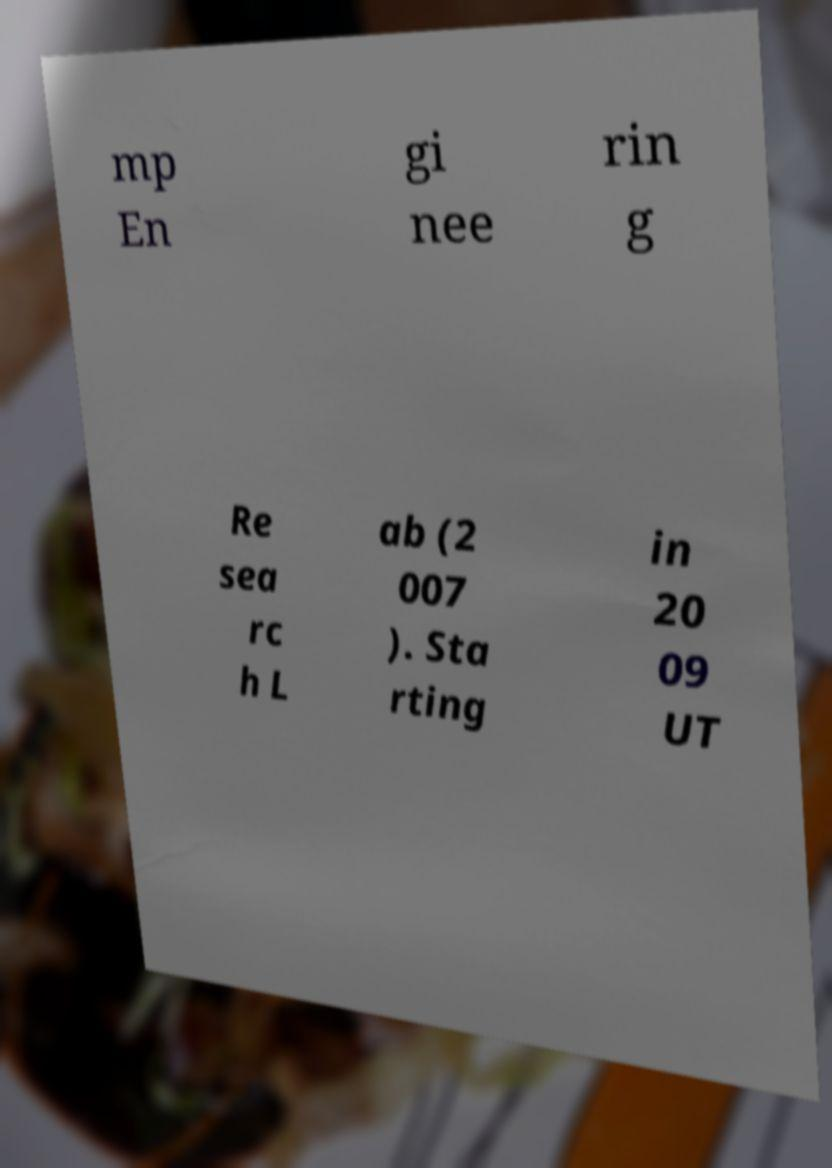Please read and relay the text visible in this image. What does it say? mp En gi nee rin g Re sea rc h L ab (2 007 ). Sta rting in 20 09 UT 